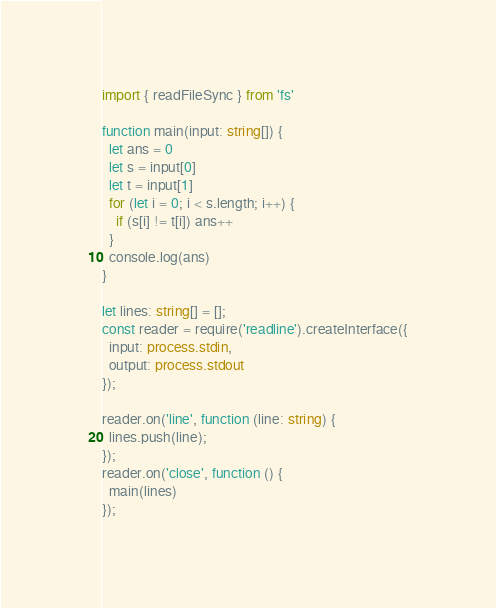Convert code to text. <code><loc_0><loc_0><loc_500><loc_500><_TypeScript_>import { readFileSync } from 'fs'

function main(input: string[]) {
  let ans = 0
  let s = input[0]
  let t = input[1]
  for (let i = 0; i < s.length; i++) {
    if (s[i] != t[i]) ans++
  }
  console.log(ans)
}

let lines: string[] = [];
const reader = require('readline').createInterface({
  input: process.stdin,
  output: process.stdout
});

reader.on('line', function (line: string) {
  lines.push(line);
});
reader.on('close', function () {
  main(lines)
});
</code> 